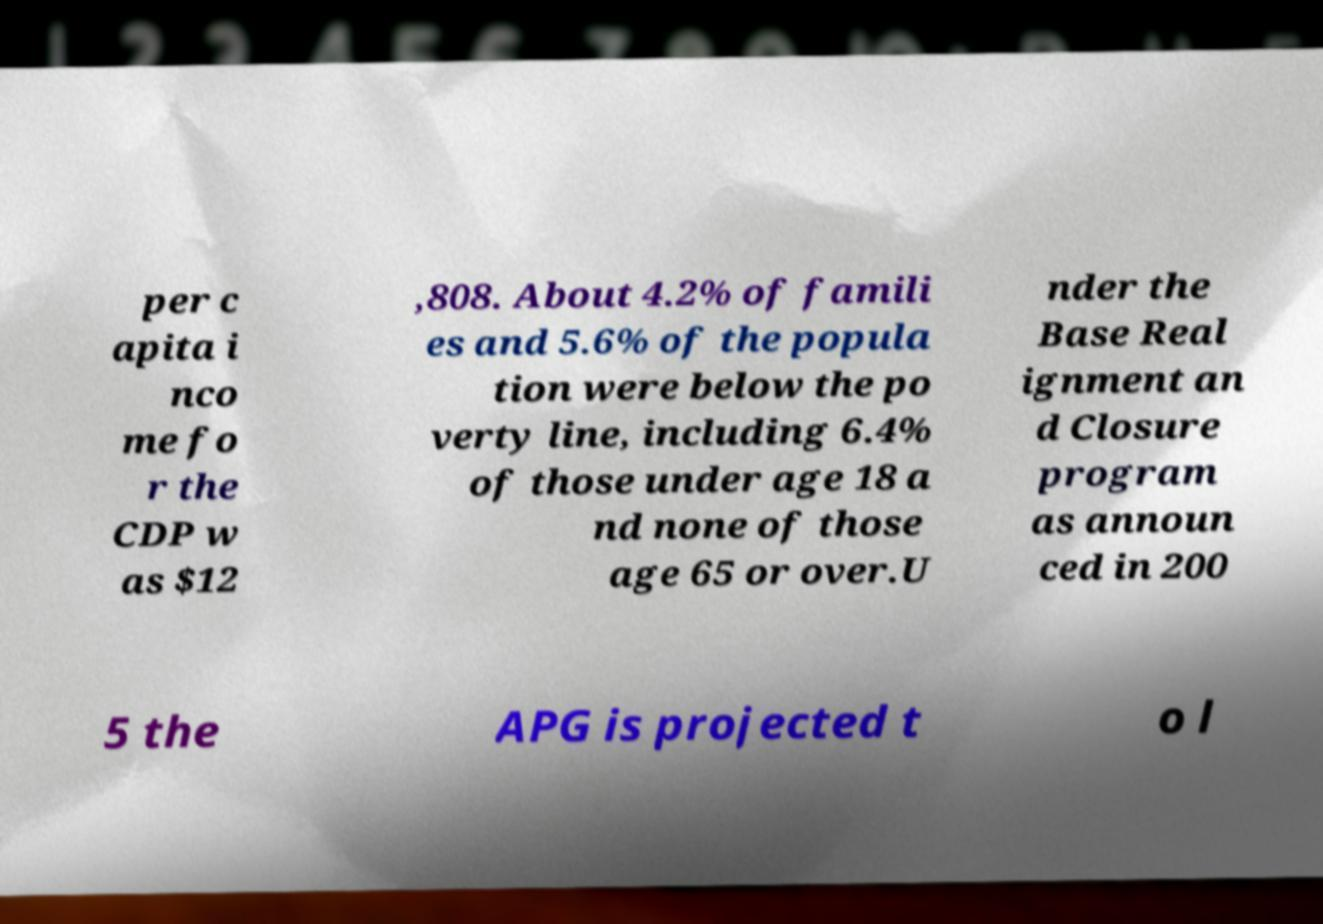Please read and relay the text visible in this image. What does it say? per c apita i nco me fo r the CDP w as $12 ,808. About 4.2% of famili es and 5.6% of the popula tion were below the po verty line, including 6.4% of those under age 18 a nd none of those age 65 or over.U nder the Base Real ignment an d Closure program as announ ced in 200 5 the APG is projected t o l 